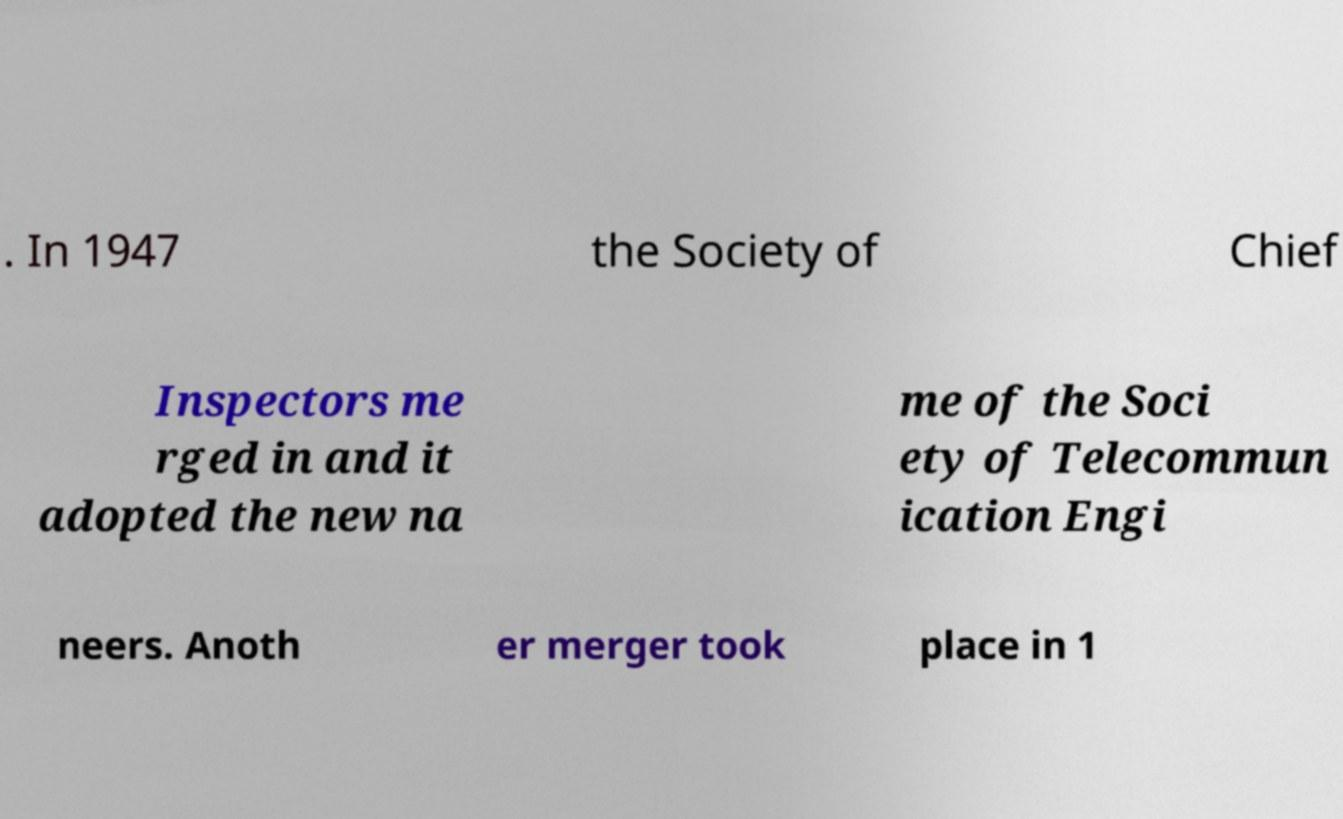Can you read and provide the text displayed in the image?This photo seems to have some interesting text. Can you extract and type it out for me? . In 1947 the Society of Chief Inspectors me rged in and it adopted the new na me of the Soci ety of Telecommun ication Engi neers. Anoth er merger took place in 1 